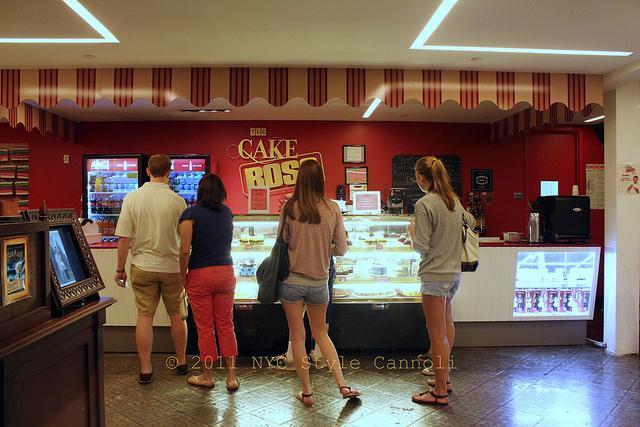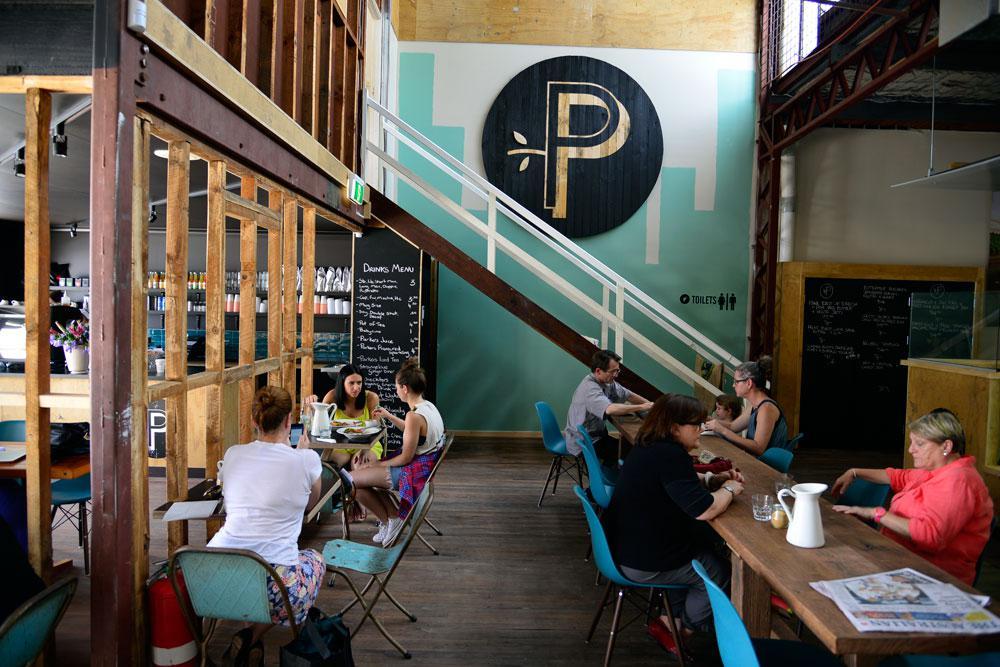The first image is the image on the left, the second image is the image on the right. Evaluate the accuracy of this statement regarding the images: "The right image shows tables and chairs for patrons, and the left image shows multiple people with backs to the camera in the foreground.". Is it true? Answer yes or no. Yes. The first image is the image on the left, the second image is the image on the right. Given the left and right images, does the statement "There is an employee of the business in one of the images." hold true? Answer yes or no. No. 